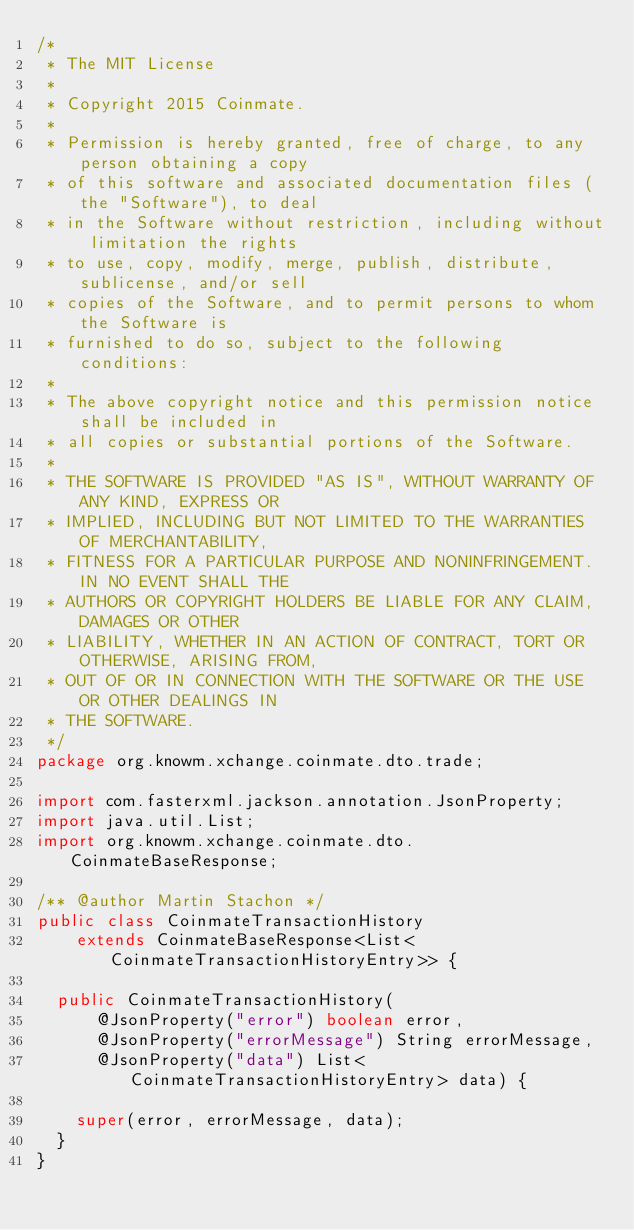Convert code to text. <code><loc_0><loc_0><loc_500><loc_500><_Java_>/*
 * The MIT License
 *
 * Copyright 2015 Coinmate.
 *
 * Permission is hereby granted, free of charge, to any person obtaining a copy
 * of this software and associated documentation files (the "Software"), to deal
 * in the Software without restriction, including without limitation the rights
 * to use, copy, modify, merge, publish, distribute, sublicense, and/or sell
 * copies of the Software, and to permit persons to whom the Software is
 * furnished to do so, subject to the following conditions:
 *
 * The above copyright notice and this permission notice shall be included in
 * all copies or substantial portions of the Software.
 *
 * THE SOFTWARE IS PROVIDED "AS IS", WITHOUT WARRANTY OF ANY KIND, EXPRESS OR
 * IMPLIED, INCLUDING BUT NOT LIMITED TO THE WARRANTIES OF MERCHANTABILITY,
 * FITNESS FOR A PARTICULAR PURPOSE AND NONINFRINGEMENT. IN NO EVENT SHALL THE
 * AUTHORS OR COPYRIGHT HOLDERS BE LIABLE FOR ANY CLAIM, DAMAGES OR OTHER
 * LIABILITY, WHETHER IN AN ACTION OF CONTRACT, TORT OR OTHERWISE, ARISING FROM,
 * OUT OF OR IN CONNECTION WITH THE SOFTWARE OR THE USE OR OTHER DEALINGS IN
 * THE SOFTWARE.
 */
package org.knowm.xchange.coinmate.dto.trade;

import com.fasterxml.jackson.annotation.JsonProperty;
import java.util.List;
import org.knowm.xchange.coinmate.dto.CoinmateBaseResponse;

/** @author Martin Stachon */
public class CoinmateTransactionHistory
    extends CoinmateBaseResponse<List<CoinmateTransactionHistoryEntry>> {

  public CoinmateTransactionHistory(
      @JsonProperty("error") boolean error,
      @JsonProperty("errorMessage") String errorMessage,
      @JsonProperty("data") List<CoinmateTransactionHistoryEntry> data) {

    super(error, errorMessage, data);
  }
}
</code> 